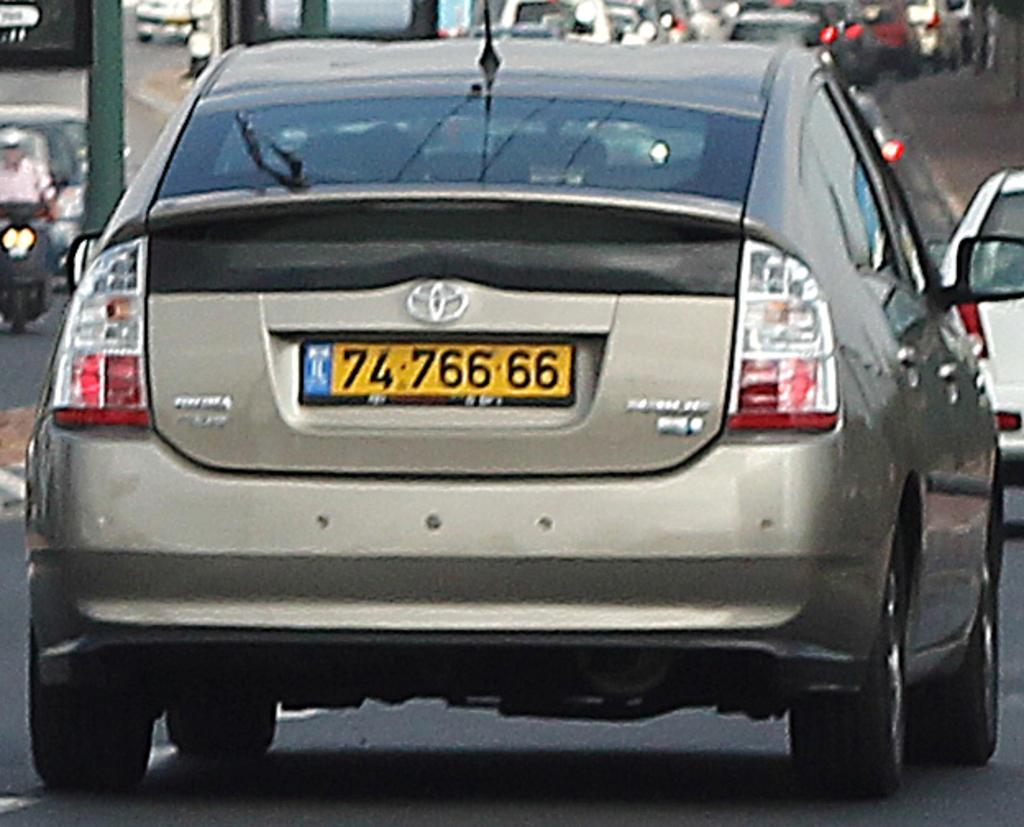Please provide a concise description of this image. In this image we can see the vehicles on the road. 